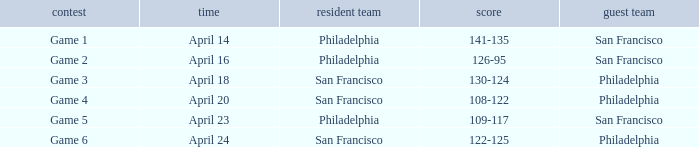What was the result of the April 16 game? 126-95. 